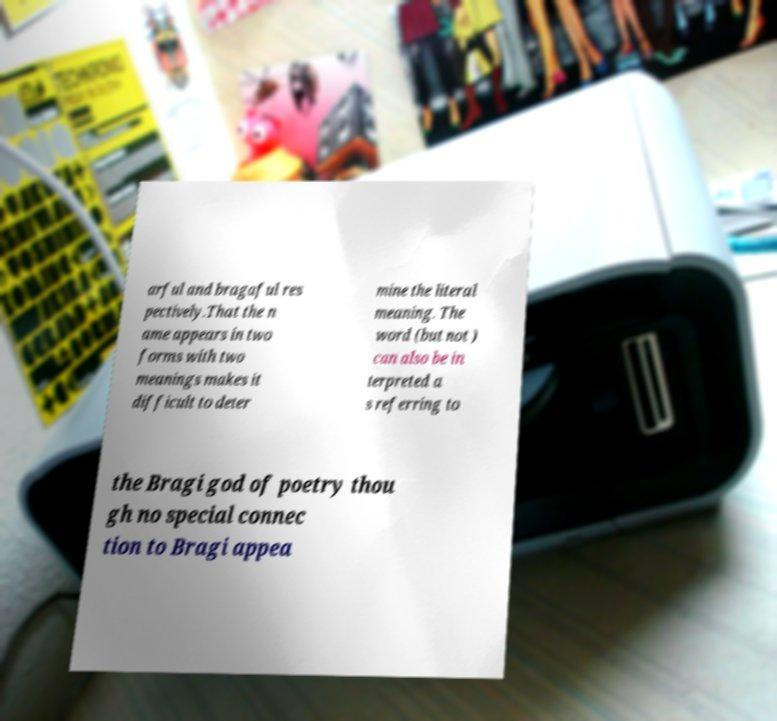Could you assist in decoding the text presented in this image and type it out clearly? arful and bragaful res pectively.That the n ame appears in two forms with two meanings makes it difficult to deter mine the literal meaning. The word (but not ) can also be in terpreted a s referring to the Bragi god of poetry thou gh no special connec tion to Bragi appea 